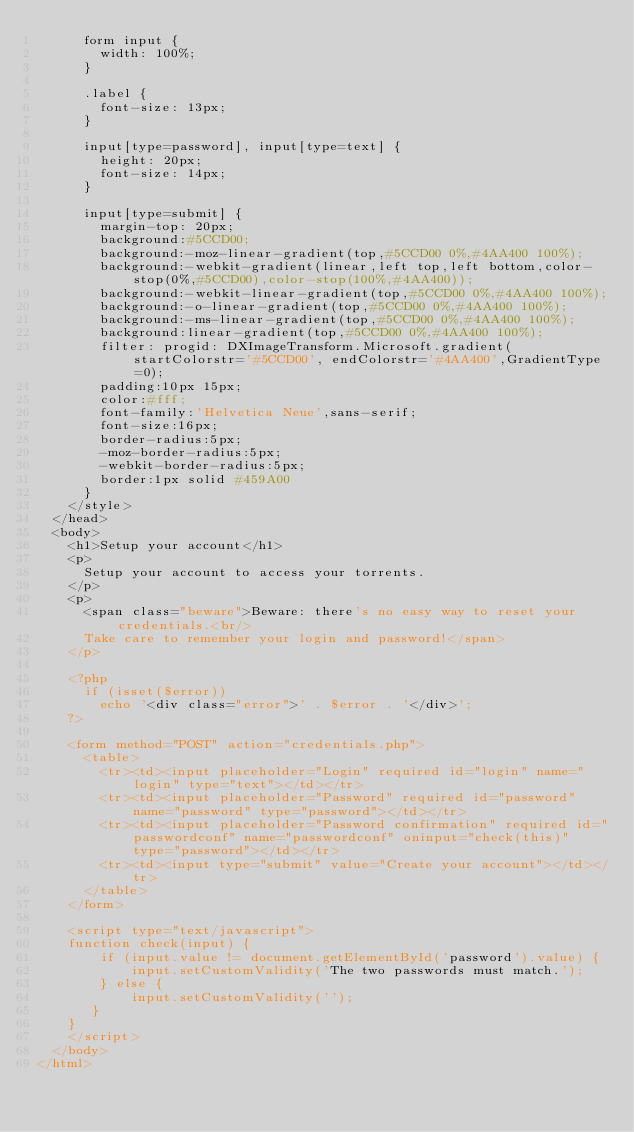<code> <loc_0><loc_0><loc_500><loc_500><_PHP_>      form input {
        width: 100%;
      }

      .label {
        font-size: 13px;
      }

      input[type=password], input[type=text] {
        height: 20px;
        font-size: 14px;
      }

      input[type=submit] {
        margin-top: 20px;
        background:#5CCD00;
        background:-moz-linear-gradient(top,#5CCD00 0%,#4AA400 100%);
        background:-webkit-gradient(linear,left top,left bottom,color-stop(0%,#5CCD00),color-stop(100%,#4AA400));
        background:-webkit-linear-gradient(top,#5CCD00 0%,#4AA400 100%);
        background:-o-linear-gradient(top,#5CCD00 0%,#4AA400 100%);
        background:-ms-linear-gradient(top,#5CCD00 0%,#4AA400 100%);
        background:linear-gradient(top,#5CCD00 0%,#4AA400 100%);
        filter: progid: DXImageTransform.Microsoft.gradient( startColorstr='#5CCD00', endColorstr='#4AA400',GradientType=0);
        padding:10px 15px;
        color:#fff;
        font-family:'Helvetica Neue',sans-serif;
        font-size:16px;
        border-radius:5px;
        -moz-border-radius:5px;
        -webkit-border-radius:5px;
        border:1px solid #459A00
      }
    </style>
  </head>
  <body>
    <h1>Setup your account</h1>
    <p>
      Setup your account to access your torrents.
    </p>
    <p>
      <span class="beware">Beware: there's no easy way to reset your credentials.<br/>
      Take care to remember your login and password!</span>
    </p>

    <?php
      if (isset($error))
        echo '<div class="error">' . $error . '</div>';
    ?>

    <form method="POST" action="credentials.php">
      <table>
        <tr><td><input placeholder="Login" required id="login" name="login" type="text"></td></tr>
        <tr><td><input placeholder="Password" required id="password" name="password" type="password"></td></tr>
        <tr><td><input placeholder="Password confirmation" required id="passwordconf" name="passwordconf" oninput="check(this)" type="password"></td></tr>
        <tr><td><input type="submit" value="Create your account"></td></tr>
      </table>
    </form>

    <script type="text/javascript">
    function check(input) {
        if (input.value != document.getElementById('password').value) {
            input.setCustomValidity('The two passwords must match.');
        } else {
            input.setCustomValidity('');
       }
    }
    </script>
  </body>
</html>
</code> 